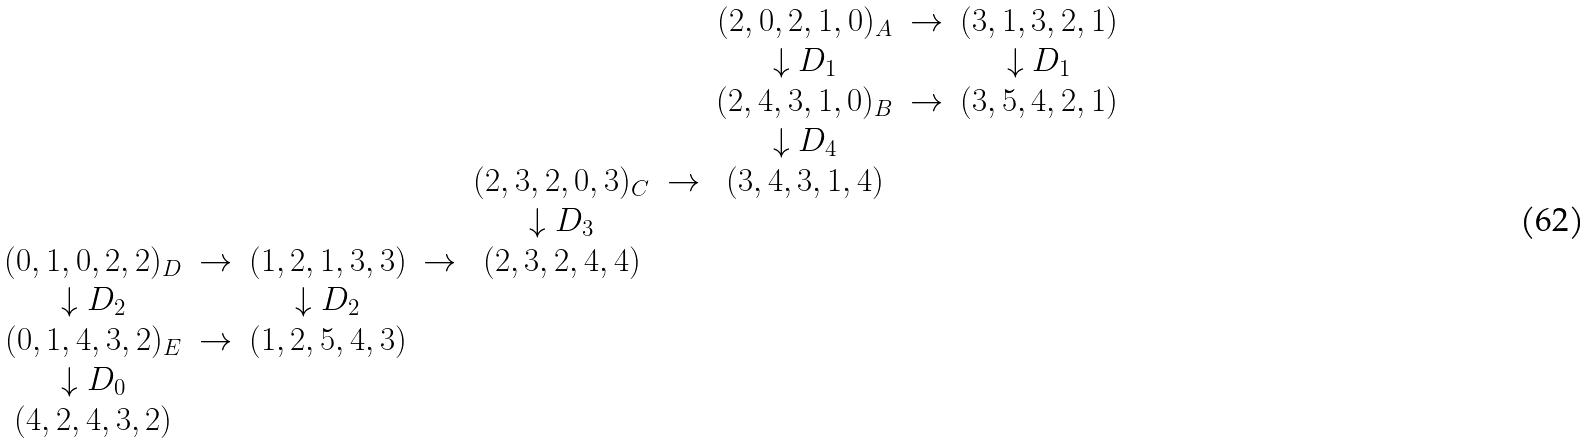Convert formula to latex. <formula><loc_0><loc_0><loc_500><loc_500>\begin{array} { c c c c c c c c c } & & & & & & ( 2 , 0 , 2 , 1 , 0 ) _ { A } & \to & ( 3 , 1 , 3 , 2 , 1 ) \\ & & & & & & \downarrow D _ { 1 } & & \downarrow D _ { 1 } \\ & & & & & & ( 2 , 4 , 3 , 1 , 0 ) _ { B } & \to & ( 3 , 5 , 4 , 2 , 1 ) \\ & & & & & & \downarrow D _ { 4 } & & \\ & & & & ( 2 , 3 , 2 , 0 , 3 ) _ { C } & \to & ( 3 , 4 , 3 , 1 , 4 ) & & \\ & & & & \downarrow D _ { 3 } & & & & \\ ( 0 , 1 , 0 , 2 , 2 ) _ { D } & \to & ( 1 , 2 , 1 , 3 , 3 ) & \to & ( 2 , 3 , 2 , 4 , 4 ) & & & & \\ \downarrow D _ { 2 } & & \downarrow D _ { 2 } & & & & & & \\ ( 0 , 1 , 4 , 3 , 2 ) _ { E } & \to & ( 1 , 2 , 5 , 4 , 3 ) & & & & & & \\ \downarrow D _ { 0 } & & & & & & & & \\ ( 4 , 2 , 4 , 3 , 2 ) & & & & & & & & \end{array}</formula> 